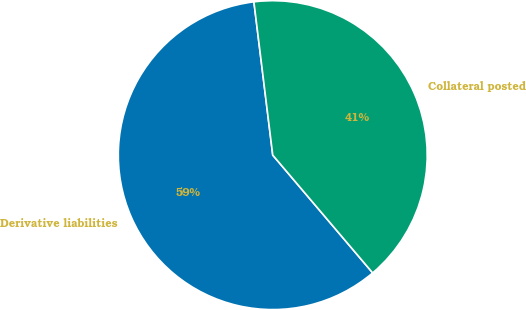Convert chart. <chart><loc_0><loc_0><loc_500><loc_500><pie_chart><fcel>Derivative liabilities<fcel>Collateral posted<nl><fcel>59.25%<fcel>40.75%<nl></chart> 